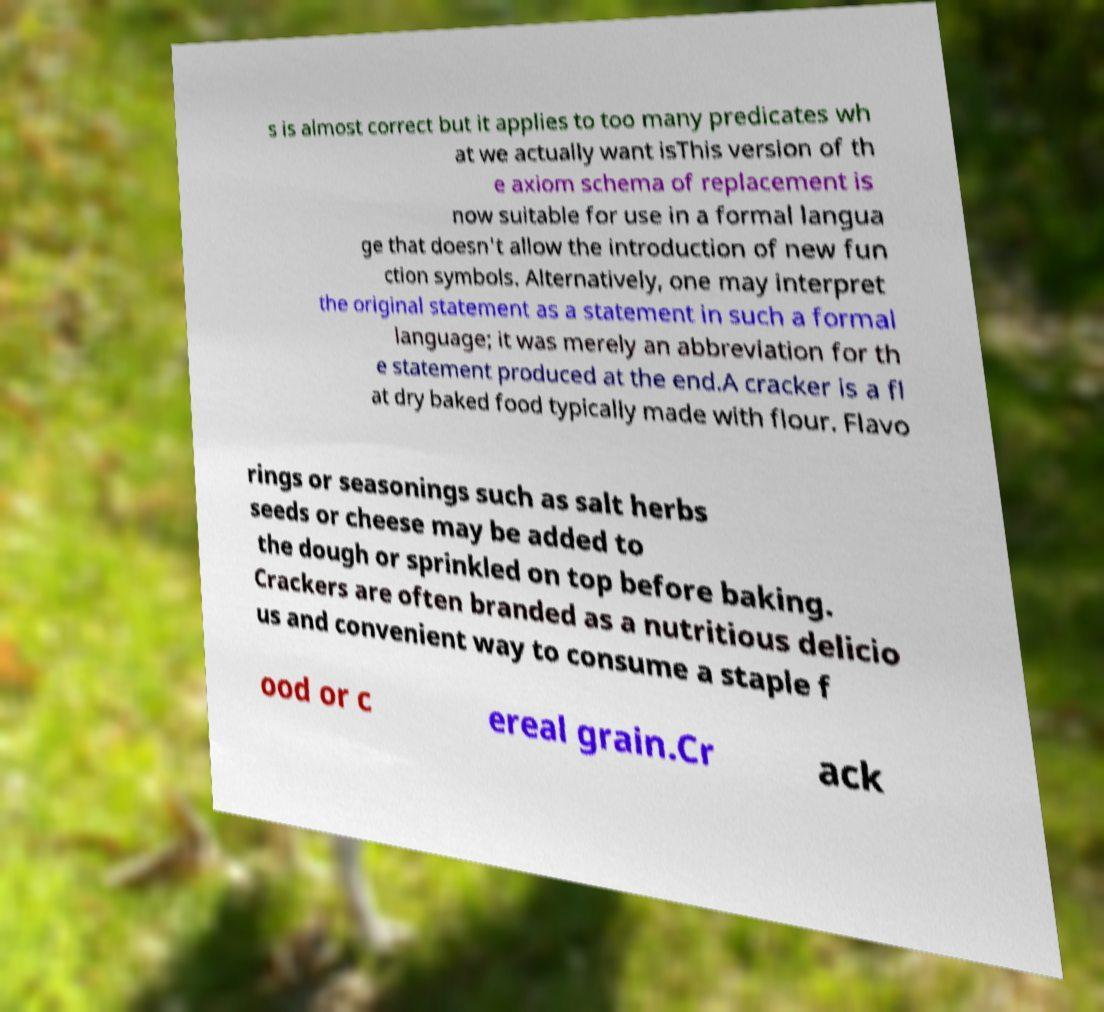I need the written content from this picture converted into text. Can you do that? s is almost correct but it applies to too many predicates wh at we actually want isThis version of th e axiom schema of replacement is now suitable for use in a formal langua ge that doesn't allow the introduction of new fun ction symbols. Alternatively, one may interpret the original statement as a statement in such a formal language; it was merely an abbreviation for th e statement produced at the end.A cracker is a fl at dry baked food typically made with flour. Flavo rings or seasonings such as salt herbs seeds or cheese may be added to the dough or sprinkled on top before baking. Crackers are often branded as a nutritious delicio us and convenient way to consume a staple f ood or c ereal grain.Cr ack 